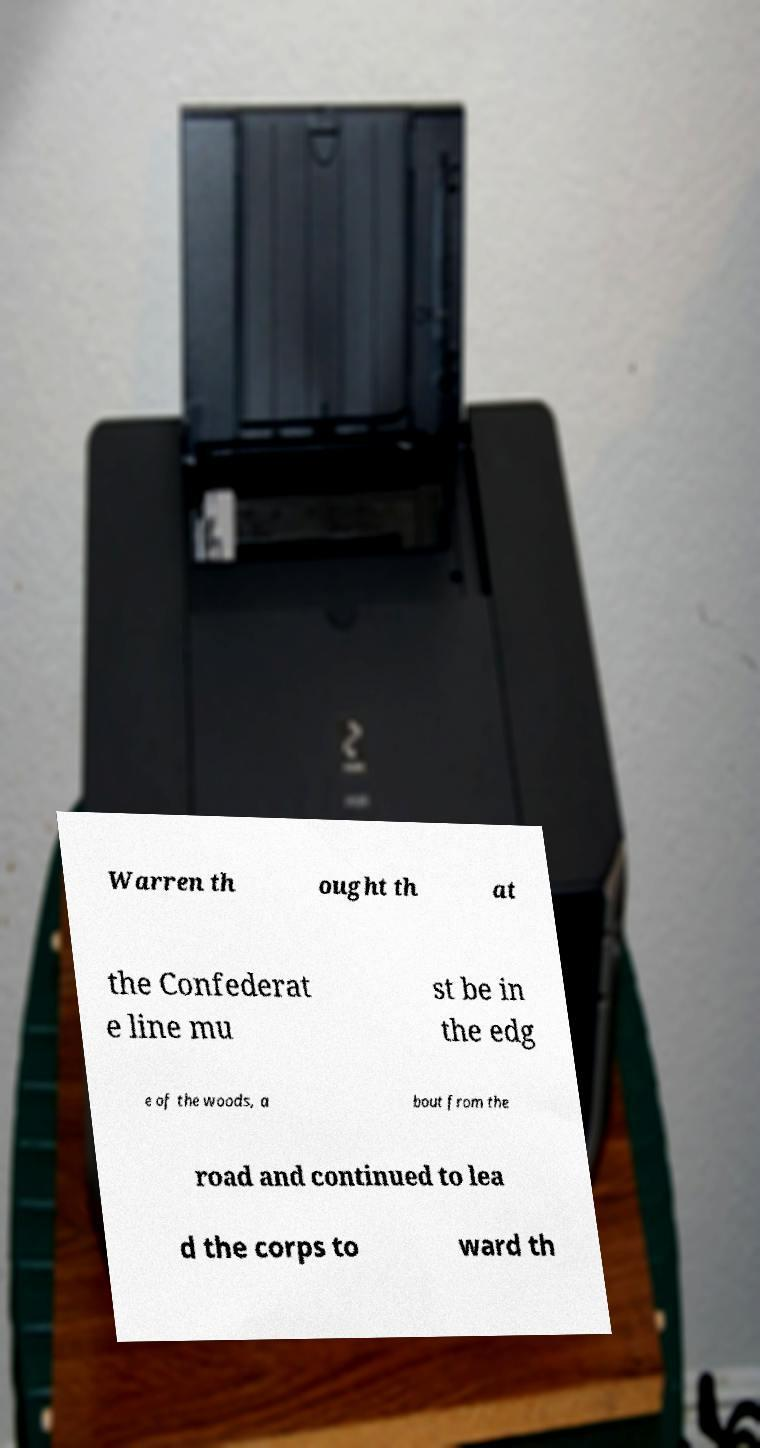There's text embedded in this image that I need extracted. Can you transcribe it verbatim? Warren th ought th at the Confederat e line mu st be in the edg e of the woods, a bout from the road and continued to lea d the corps to ward th 